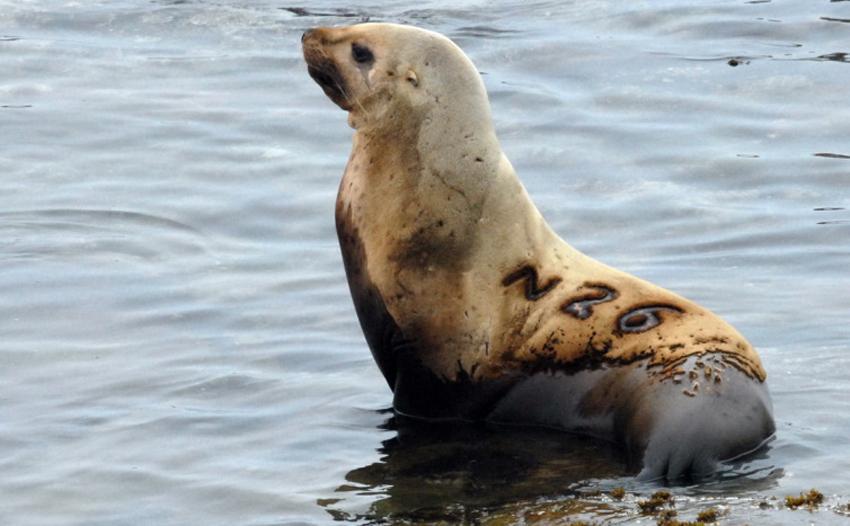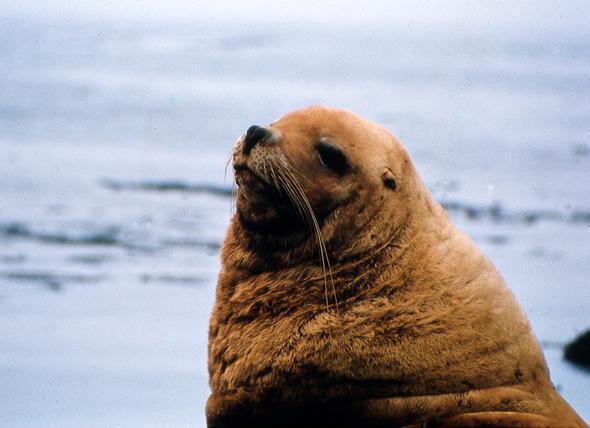The first image is the image on the left, the second image is the image on the right. Examine the images to the left and right. Is the description "In at least one image there is a lone seal sitting in shallow water" accurate? Answer yes or no. Yes. The first image is the image on the left, the second image is the image on the right. For the images shown, is this caption "One seal is in the water facing left in one image." true? Answer yes or no. Yes. 